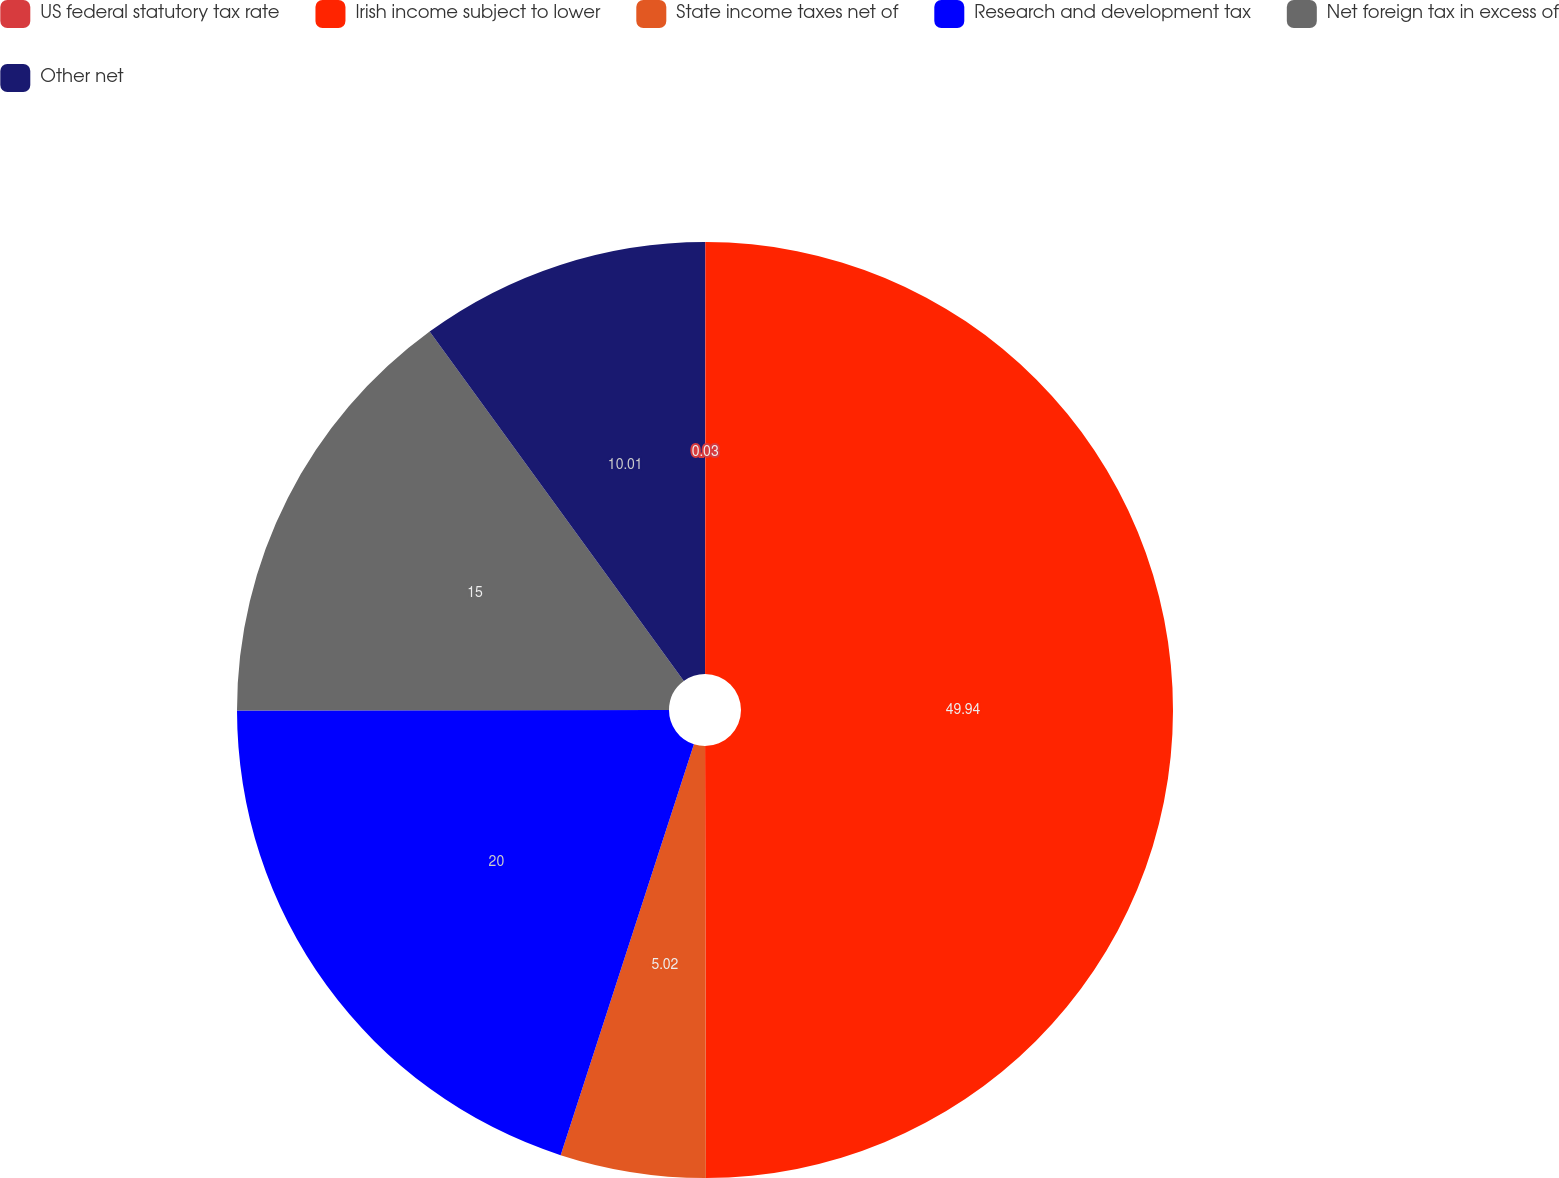Convert chart. <chart><loc_0><loc_0><loc_500><loc_500><pie_chart><fcel>US federal statutory tax rate<fcel>Irish income subject to lower<fcel>State income taxes net of<fcel>Research and development tax<fcel>Net foreign tax in excess of<fcel>Other net<nl><fcel>0.03%<fcel>49.93%<fcel>5.02%<fcel>19.99%<fcel>15.0%<fcel>10.01%<nl></chart> 